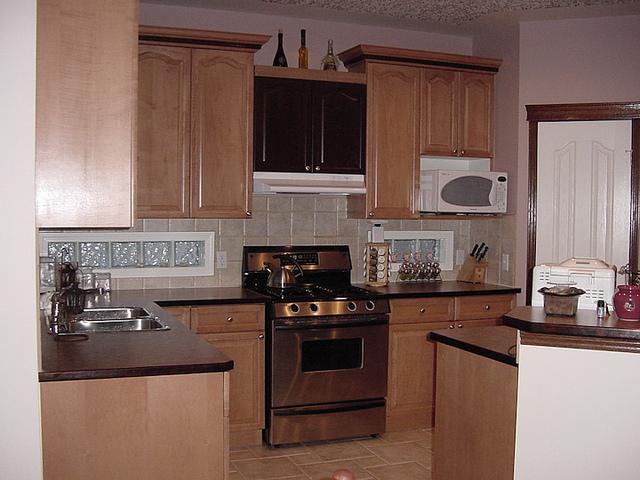What is the item on the stove for?
Be succinct. Tea. Are the cabinets brown?
Answer briefly. Yes. What color are the countertops?
Keep it brief. Brown. Where is the sink?
Be succinct. Left. How many drawers are in the kitchen?
Answer briefly. 4. What type of floor?
Write a very short answer. Tile. What color is the stove?
Short answer required. Silver. What number of tiles are on the small section over the stove?
Give a very brief answer. 12. What material is the range made of?
Answer briefly. Stainless steel. What is on the floor in front of the sink?
Quick response, please. Ball. What kind of material is the countertop made out of?
Keep it brief. Wood. 